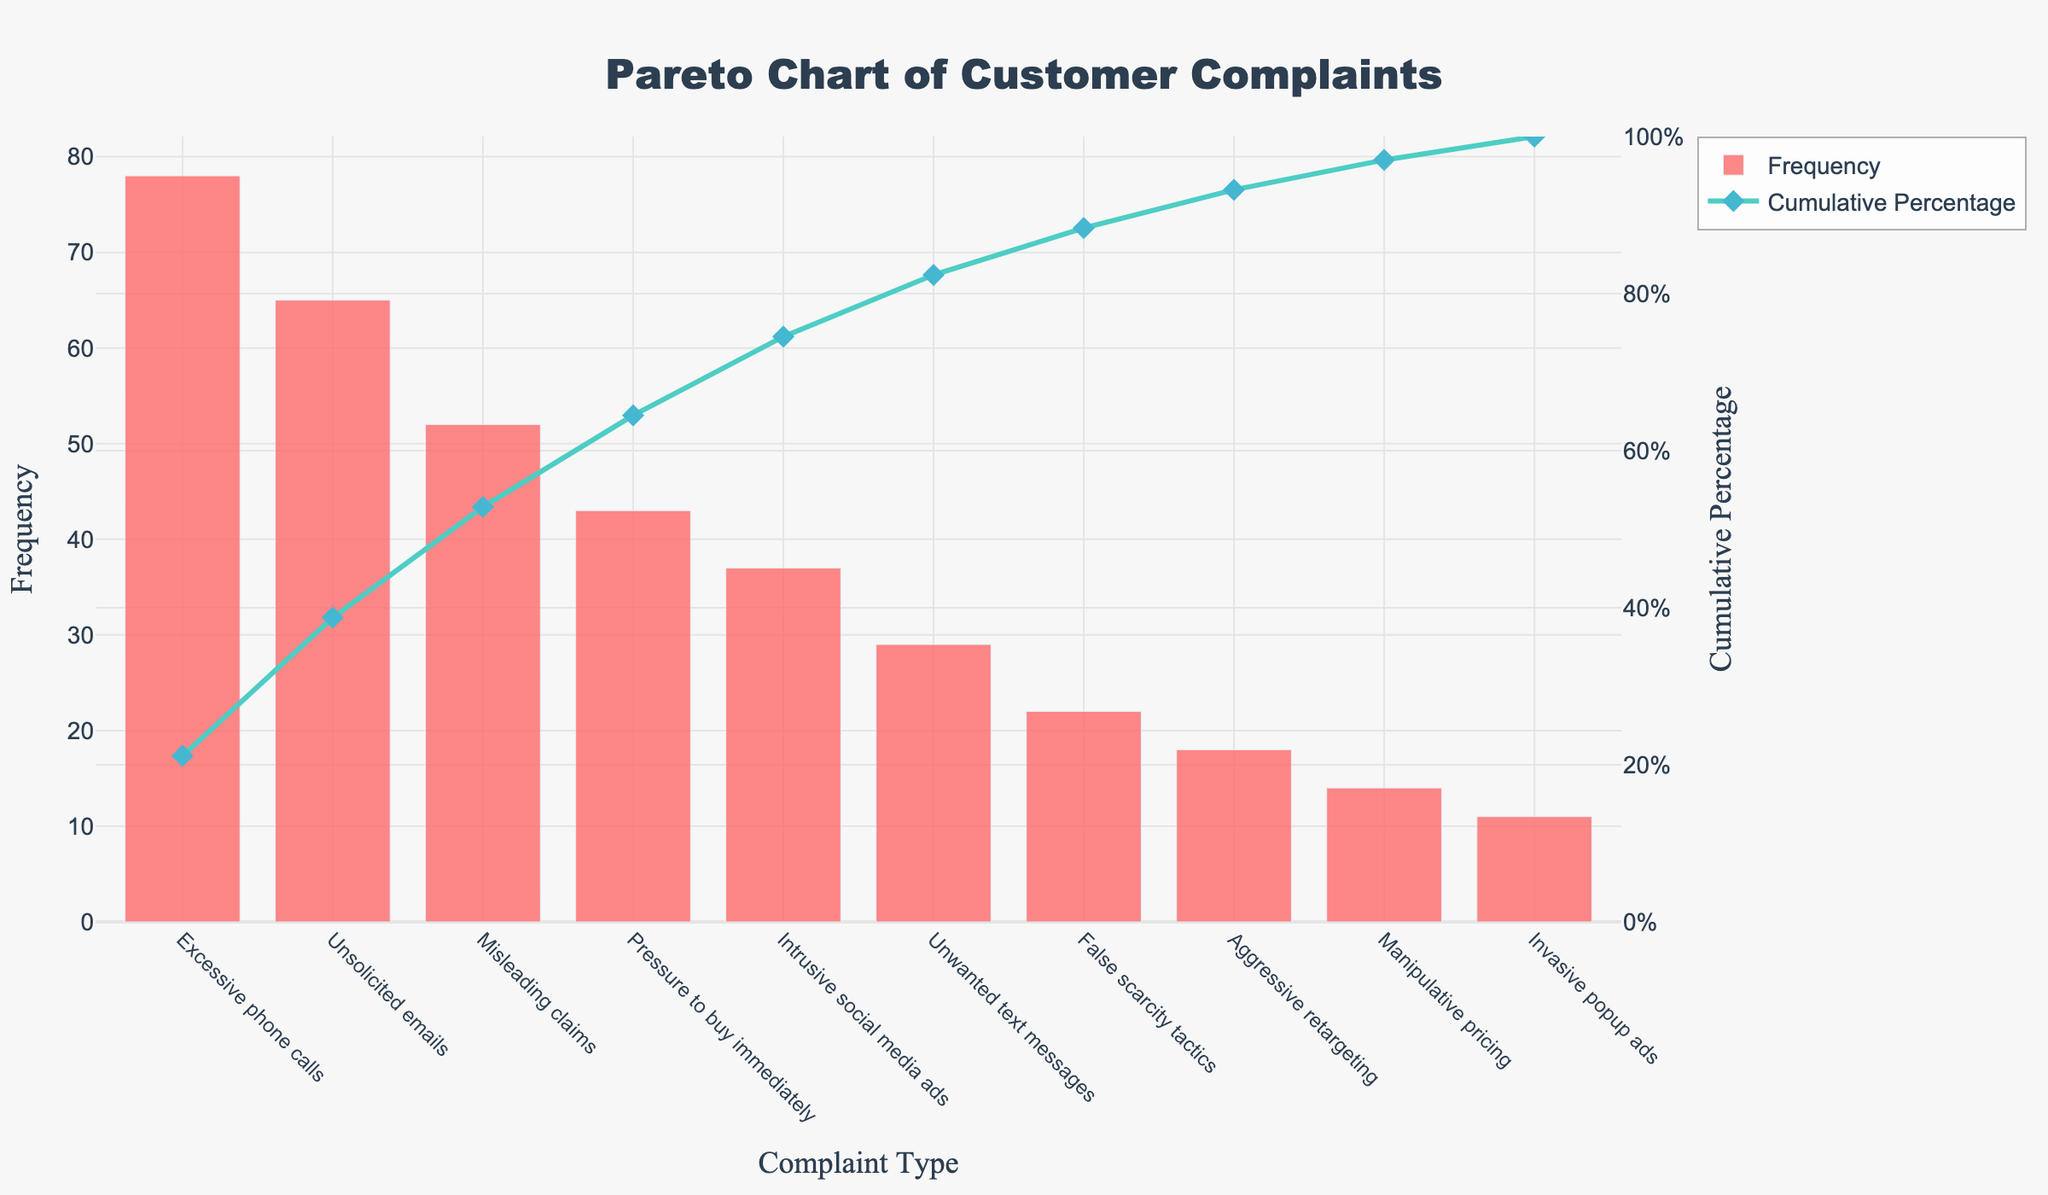What is the title of the chart? The title of the chart is located at the top and it reads: "Pareto Chart of Customer Complaints".
Answer: Pareto Chart of Customer Complaints Which complaint type has the highest frequency? The chart shows bars representing the frequency of each complaint type. The tallest bar corresponds to "Excessive phone calls".
Answer: Excessive phone calls What is the cumulative percentage for "Misleading claims"? Locate the "Misleading claims" category on the x-axis, then look at the corresponding point on the cumulative percentage line, which is represented by a diamond marker. The point falls between 40% and 60%. Looking closely, it approximates to around 59%.
Answer: Around 59% Which complaint type contributes to crossing the 80% cumulative percentage mark? Follow the cumulative percentage line until it crosses the 80% mark. The bar and corresponding label below the crossing point will indicate the contributing complaint type. The cumulative percentage crosses 80% after "Unwanted text messages".
Answer: Unwanted text messages How many complaint types cumulatively account for roughly 50% of the total complaints? Begin from the leftmost bar and cumulatively add the frequencies. Then check the cumulative percentage line for the 50% mark. The types that together make up approximately 50% are "Excessive phone calls", "Unsolicited emails", and "Misleading claims". 3 types account for roughly 50%.
Answer: 3 complaint types What is the y-axis title for the left and right axes? Locate the titles adjacent to the y-axes. The left y-axis is titled "Frequency", and the right y-axis is titled "Cumulative Percentage".
Answer: Frequency (left) and Cumulative Percentage (right) How does the frequency of "Pressure to buy immediately" compare to "Intrusive social media ads"? Look at the heights of the bars corresponding to these complaint types. "Pressure to buy immediately" is taller with a frequency of 43, whereas "Intrusive social media ads" has a frequency of 37.
Answer: "Pressure to buy immediately" has a higher frequency What is the total number of complaints recorded? To find the total, sum the frequencies of all the complaint types shown in the bars. (78 + 65 + 52 + 43 + 37 + 29 + 22 + 18 + 14 + 11). The total is 369.
Answer: 369 Which two complaint types combined have a similar frequency to "Excessive phone calls"? Identify "Excessive phone calls" frequency which is 78. Now, find any two bars whose heights combined sum up close to 78. "Unsolicited emails" (65) and "False scarcity tactics" (22) combined have 87, which is close.
Answer: “Unsolicited emails” and “False scarcity tactics” What complaint types lie between 20% and 60% in cumulative percentage? Locate the cumulative percentage line and follow it between the 20% and 60% marks. Check the corresponding bars underneath this range. They are "Unsolicited emails", "Misleading claims", and "Pressure to buy immediately".
Answer: "Unsolicited emails", "Misleading claims", and "Pressure to buy immediately" 